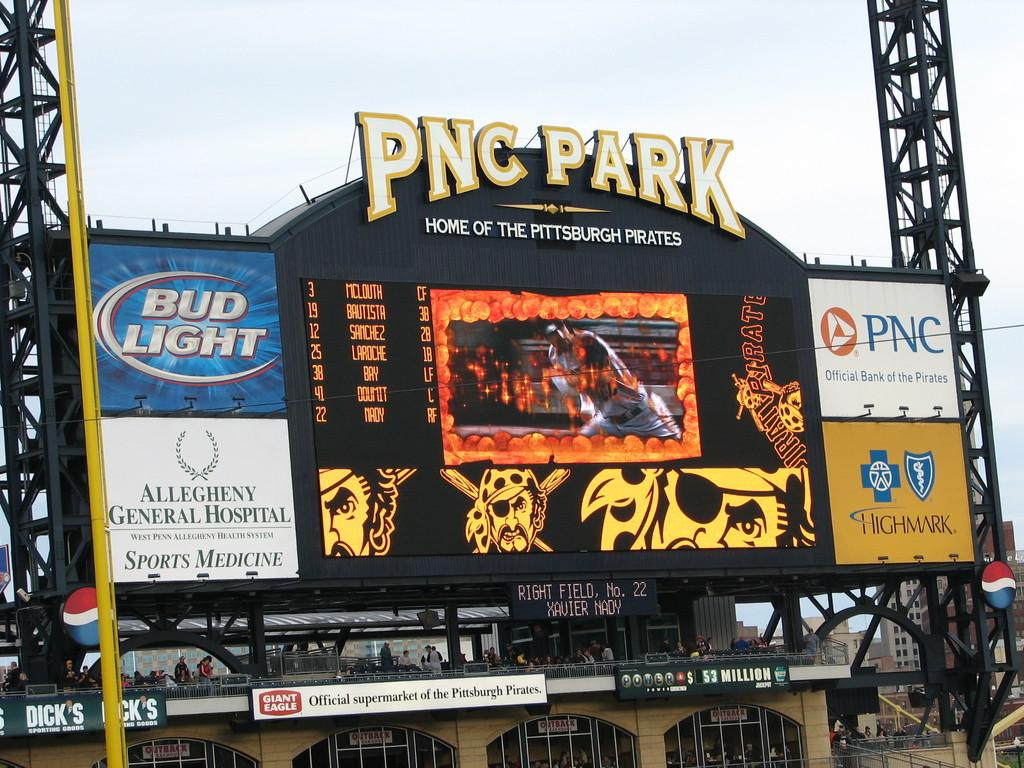<image>
Give a short and clear explanation of the subsequent image. Pictured is the PNC Park, Home of the Pittsburgh Pirates, scoreboard with advertisements from Bud Light and HighMark. 